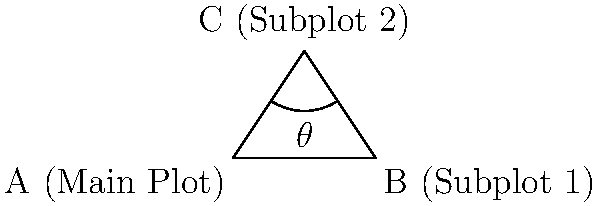In the diagram representing the narrative structure of a TV series, the main plot (A) intersects with two subplots (B and C). If the angle between the two subplots (∠ACB) is 60°, what is the value of $\theta$, the angle between the main plot and Subplot 1? To solve this problem, we'll use our knowledge of triangle geometry:

1. In any triangle, the sum of all interior angles is always 180°.

2. The diagram shows a triangle ABC, where:
   - A represents the main plot
   - B represents Subplot 1
   - C represents Subplot 2

3. We're given that ∠ACB = 60°.

4. Let's denote the unknown angle ∠CAB as $\theta$.

5. The remaining angle, ∠ABC, can be represented as $(180° - 60° - \theta)$.

6. Now, we can set up an equation based on the fact that these three angles must sum to 180°:

   $\theta + 60° + (180° - 60° - \theta) = 180°$

7. Simplify:
   $\theta + 60° + 180° - 60° - \theta = 180°$
   $180° = 180°$

8. This equation is always true, regardless of the value of $\theta$. This means the problem is indeterminate - we don't have enough information to solve for $\theta$.

9. In narrative terms, this indeterminacy reflects the flexibility in how a main plot can interact with subplots. The relationship between the main plot and Subplot 1 could vary widely while still maintaining the same relationship between the two subplots.
Answer: Indeterminate 